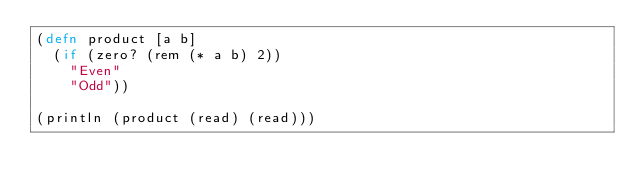Convert code to text. <code><loc_0><loc_0><loc_500><loc_500><_Clojure_>(defn product [a b]
  (if (zero? (rem (* a b) 2))
    "Even"
    "Odd"))

(println (product (read) (read)))</code> 